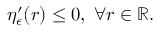Convert formula to latex. <formula><loc_0><loc_0><loc_500><loc_500>\eta _ { \epsilon } ^ { \prime } ( r ) \leq 0 , \, \forall r \in \mathbb { R } .</formula> 